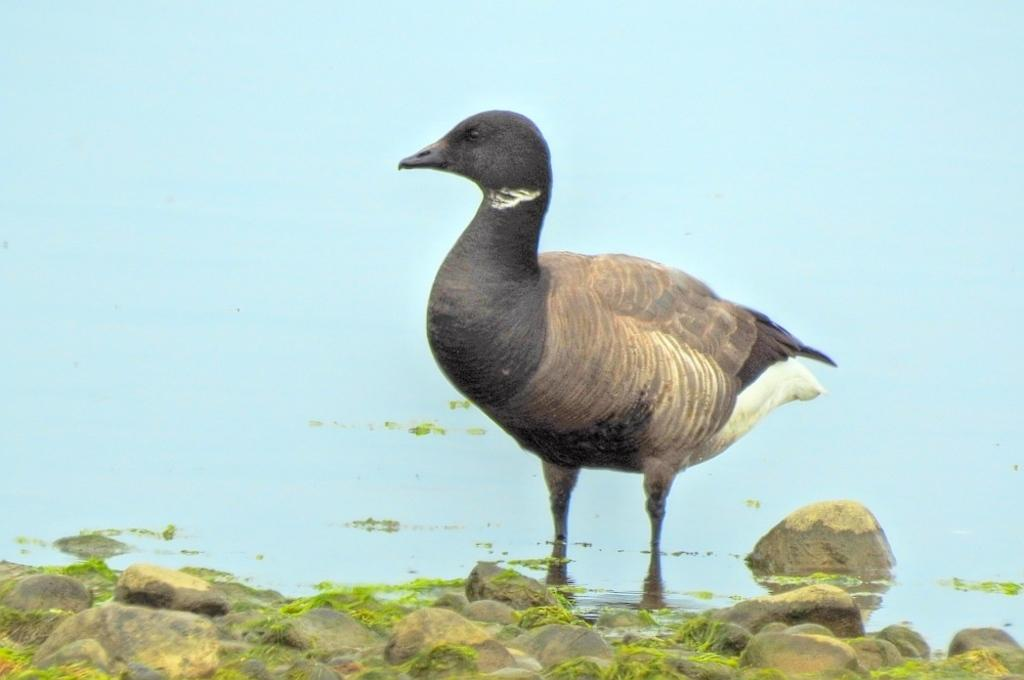What is the primary element in the image? There is water in the image. What can be seen in the water? There is a bird standing in the water. What is visible in the foreground of the image? In the foreground, there are stones with grass. What degree does the bird have in the image? There is no indication of the bird having a degree in the image. Where is the meeting taking place in the image? There is no meeting present in the image. 